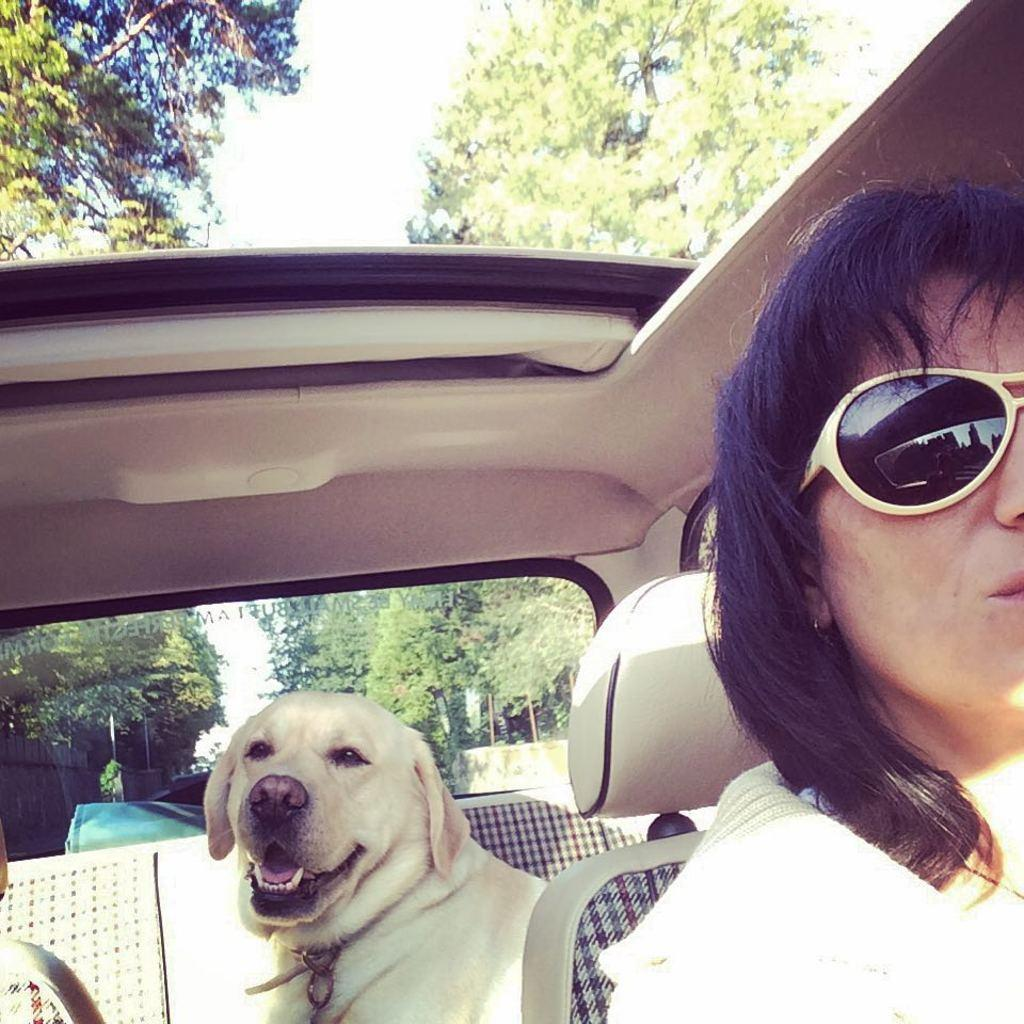Who is present in the image? There is a woman in the image. What other living creature is present in the image? There is a dog in the image. Where are the woman and the dog located? Both the woman and the dog are sitting inside a vehicle. What is the woman wearing in the image? The woman is wearing goggles. What can be seen in the background of the image? There are trees visible in the image. How many pigs are playing in the park in the image? There are no pigs or parks present in the image. Are there any spiders visible on the trees in the image? There is no mention of spiders in the image, and the focus is on the woman, the dog, and the trees. 